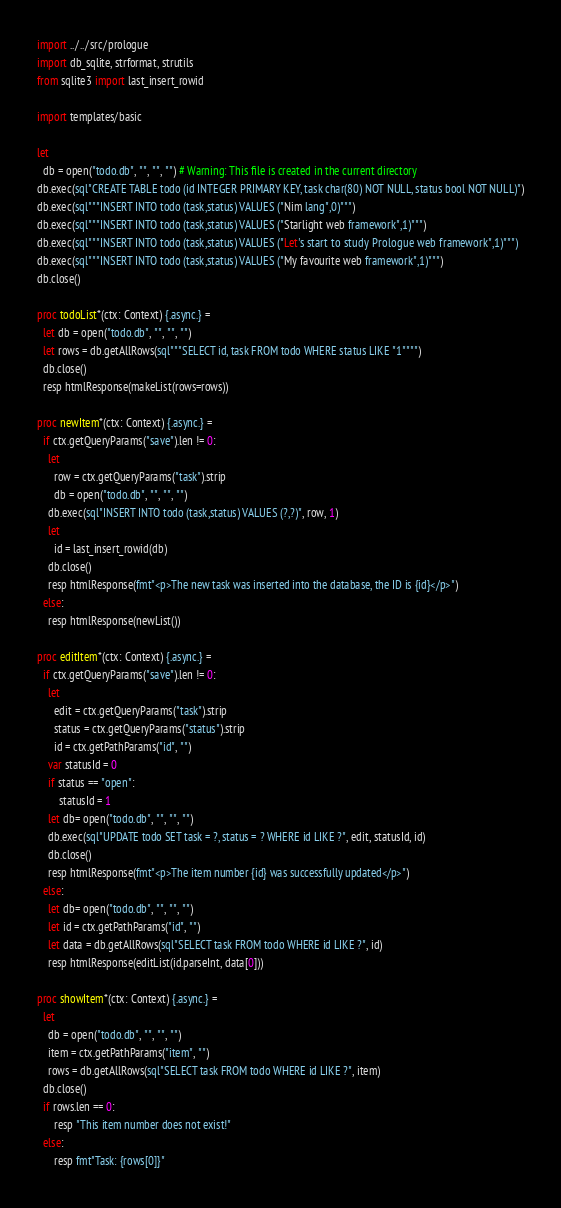<code> <loc_0><loc_0><loc_500><loc_500><_Nim_>import ../../src/prologue
import db_sqlite, strformat, strutils
from sqlite3 import last_insert_rowid

import templates/basic

let 
  db = open("todo.db", "", "", "") # Warning: This file is created in the current directory
db.exec(sql"CREATE TABLE todo (id INTEGER PRIMARY KEY, task char(80) NOT NULL, status bool NOT NULL)")
db.exec(sql"""INSERT INTO todo (task,status) VALUES ("Nim lang",0)""")
db.exec(sql"""INSERT INTO todo (task,status) VALUES ("Starlight web framework",1)""")
db.exec(sql"""INSERT INTO todo (task,status) VALUES ("Let's start to study Prologue web framework",1)""")
db.exec(sql"""INSERT INTO todo (task,status) VALUES ("My favourite web framework",1)""")
db.close()

proc todoList*(ctx: Context) {.async.} =
  let db = open("todo.db", "", "", "")
  let rows = db.getAllRows(sql"""SELECT id, task FROM todo WHERE status LIKE "1"""")
  db.close()
  resp htmlResponse(makeList(rows=rows))

proc newItem*(ctx: Context) {.async.} =
  if ctx.getQueryParams("save").len != 0:
    let
      row = ctx.getQueryParams("task").strip
      db = open("todo.db", "", "", "")
    db.exec(sql"INSERT INTO todo (task,status) VALUES (?,?)", row, 1)
    let
      id = last_insert_rowid(db)
    db.close()
    resp htmlResponse(fmt"<p>The new task was inserted into the database, the ID is {id}</p>")
  else:
    resp htmlResponse(newList())

proc editItem*(ctx: Context) {.async.} =
  if ctx.getQueryParams("save").len != 0:
    let
      edit = ctx.getQueryParams("task").strip
      status = ctx.getQueryParams("status").strip
      id = ctx.getPathParams("id", "")
    var statusId = 0
    if status == "open":
        statusId = 1
    let db= open("todo.db", "", "", "")
    db.exec(sql"UPDATE todo SET task = ?, status = ? WHERE id LIKE ?", edit, statusId, id)
    db.close()
    resp htmlResponse(fmt"<p>The item number {id} was successfully updated</p>")
  else:
    let db= open("todo.db", "", "", "")
    let id = ctx.getPathParams("id", "")
    let data = db.getAllRows(sql"SELECT task FROM todo WHERE id LIKE ?", id)
    resp htmlResponse(editList(id.parseInt, data[0]))

proc showItem*(ctx: Context) {.async.} =
  let
    db = open("todo.db", "", "", "")
    item = ctx.getPathParams("item", "")
    rows = db.getAllRows(sql"SELECT task FROM todo WHERE id LIKE ?", item)
  db.close()
  if rows.len == 0:
      resp "This item number does not exist!"
  else:
      resp fmt"Task: {rows[0]}"
</code> 